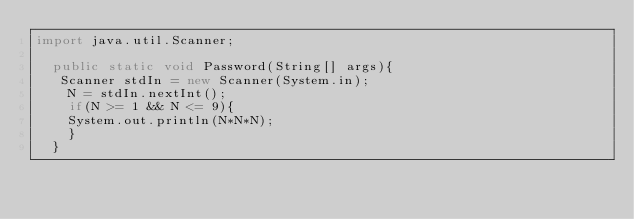Convert code to text. <code><loc_0><loc_0><loc_500><loc_500><_Java_>import java.util.Scanner;

  public static void Password(String[] args){
   Scanner stdIn = new Scanner(System.in);
    N = stdIn.nextInt();
    if(N >= 1 && N <= 9){
    System.out.println(N*N*N);
    }
  }</code> 